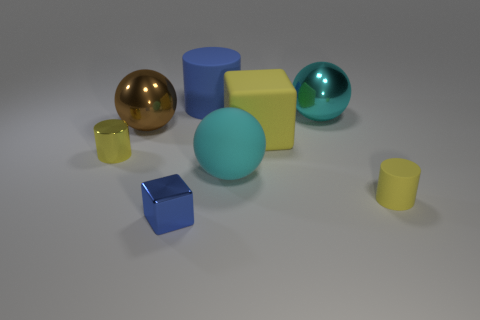What is the color of the tiny metal object that is the same shape as the big blue matte object?
Offer a very short reply. Yellow. How many matte spheres have the same color as the metal block?
Your response must be concise. 0. Do the yellow shiny thing and the cyan matte sphere have the same size?
Your response must be concise. No. What material is the small blue cube?
Ensure brevity in your answer.  Metal. There is a big cylinder that is made of the same material as the large yellow thing; what is its color?
Offer a very short reply. Blue. Does the big yellow object have the same material as the tiny yellow object that is right of the tiny blue shiny thing?
Keep it short and to the point. Yes. How many blue cylinders have the same material as the big brown object?
Keep it short and to the point. 0. There is a blue object to the right of the blue metallic cube; what is its shape?
Provide a succinct answer. Cylinder. Does the big sphere in front of the yellow metal cylinder have the same material as the small yellow thing to the right of the small blue cube?
Provide a short and direct response. Yes. Are there any other big blue objects that have the same shape as the blue rubber thing?
Ensure brevity in your answer.  No. 